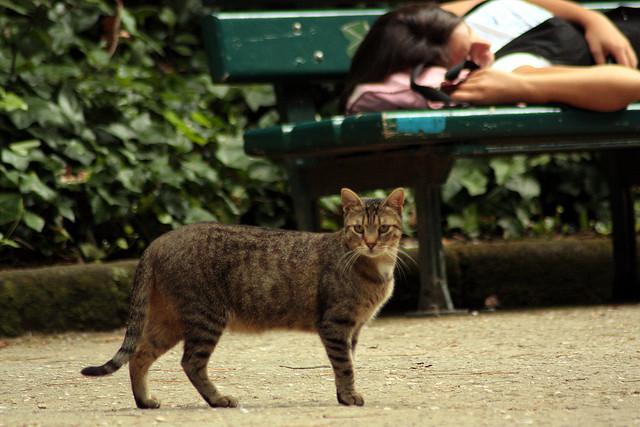What is the woman doing?
Be succinct. Sleeping. What color is the green?
Answer briefly. Green. What color is the pillow?
Concise answer only. Pink. What color is the cat?
Give a very brief answer. Brown. What is this animal?
Concise answer only. Cat. 